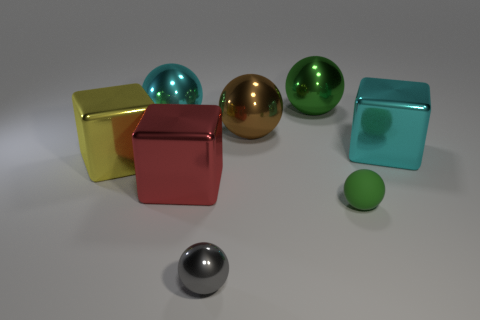There is a big green ball that is to the right of the brown shiny thing; what material is it?
Provide a succinct answer. Metal. Is the shape of the tiny thing that is to the left of the brown sphere the same as  the large brown metal thing?
Offer a terse response. Yes. Is there a yellow shiny block that has the same size as the red thing?
Make the answer very short. Yes. Is the shape of the big green thing the same as the green thing that is in front of the red metallic object?
Your response must be concise. Yes. The metal object that is the same color as the tiny rubber ball is what shape?
Give a very brief answer. Sphere. Are there fewer brown metal balls in front of the yellow metal cube than brown metal objects?
Offer a terse response. Yes. Do the large yellow metallic object and the large red shiny object have the same shape?
Keep it short and to the point. Yes. There is a red block that is the same material as the cyan ball; what is its size?
Offer a very short reply. Large. Are there fewer red metallic cubes than blue matte balls?
Your answer should be very brief. No. How many small objects are either brown metal things or cylinders?
Offer a terse response. 0. 